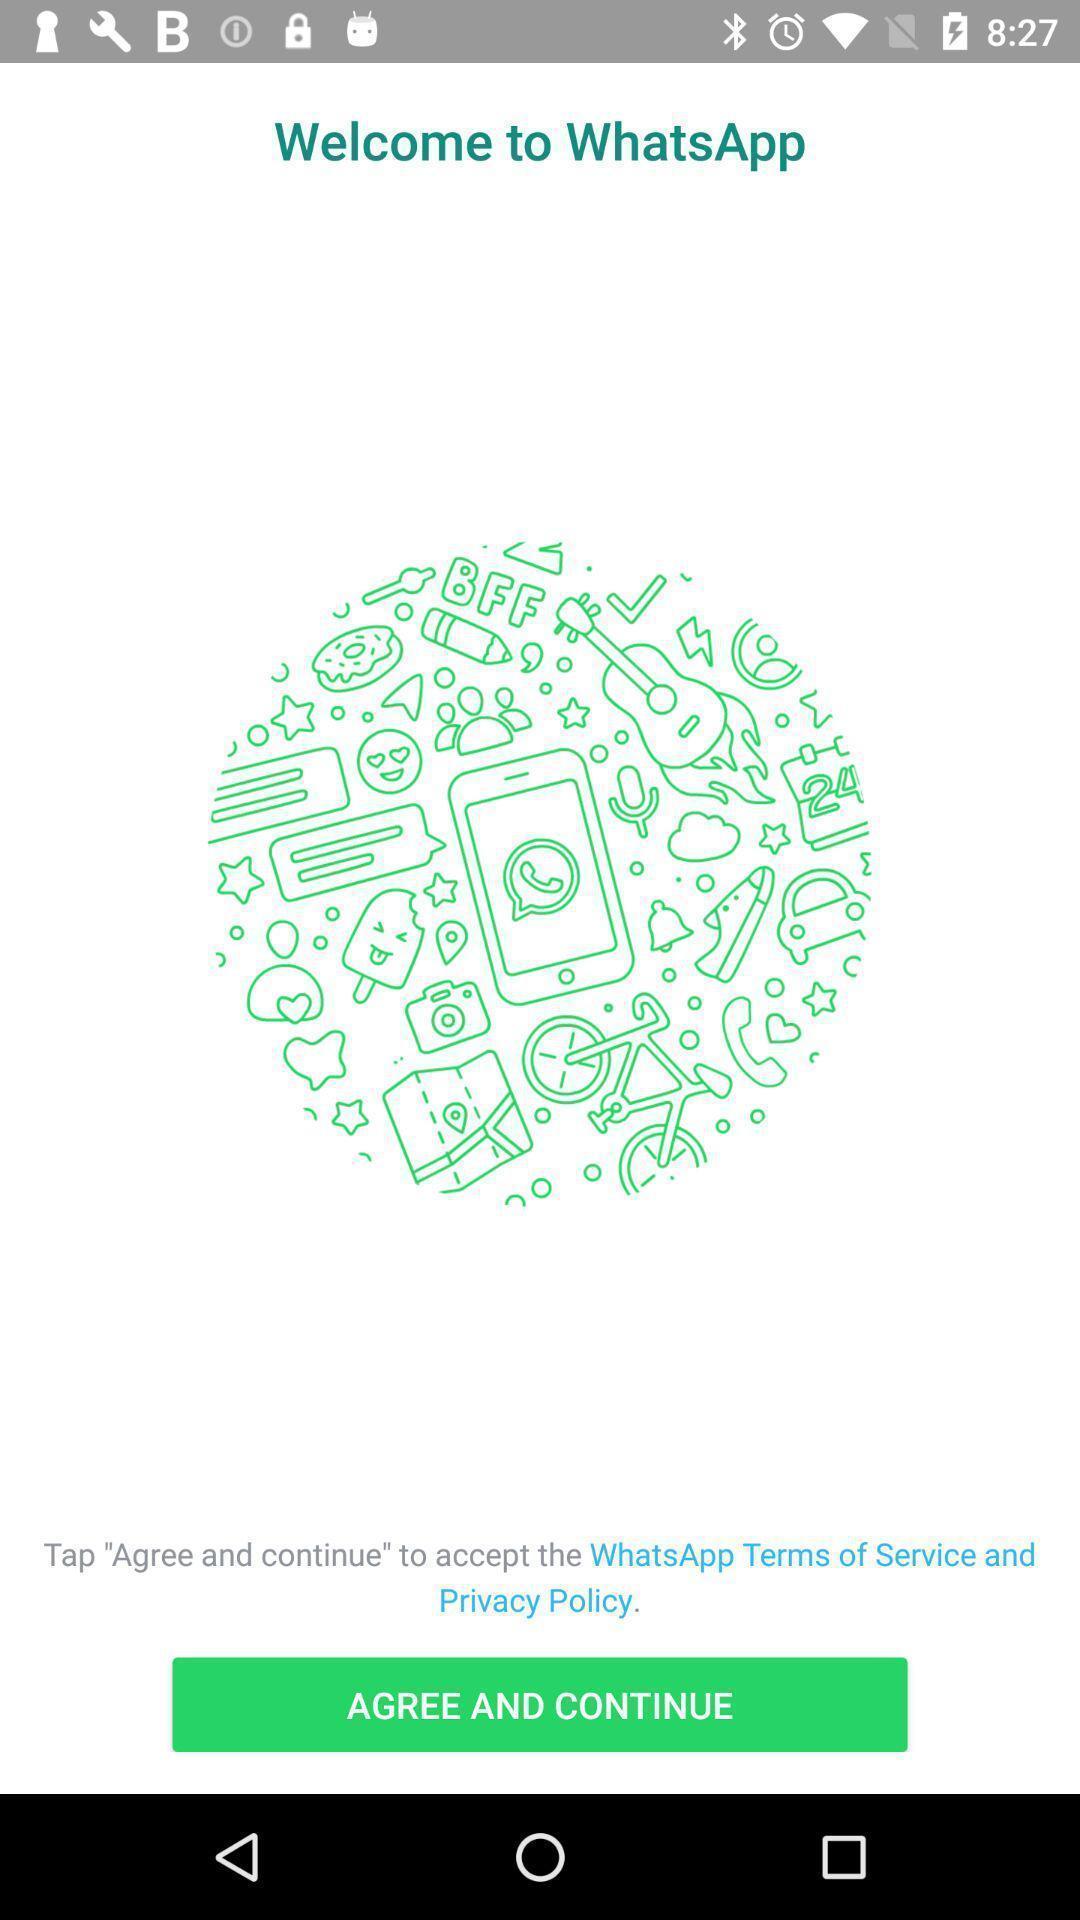Please provide a description for this image. Welcome page. 